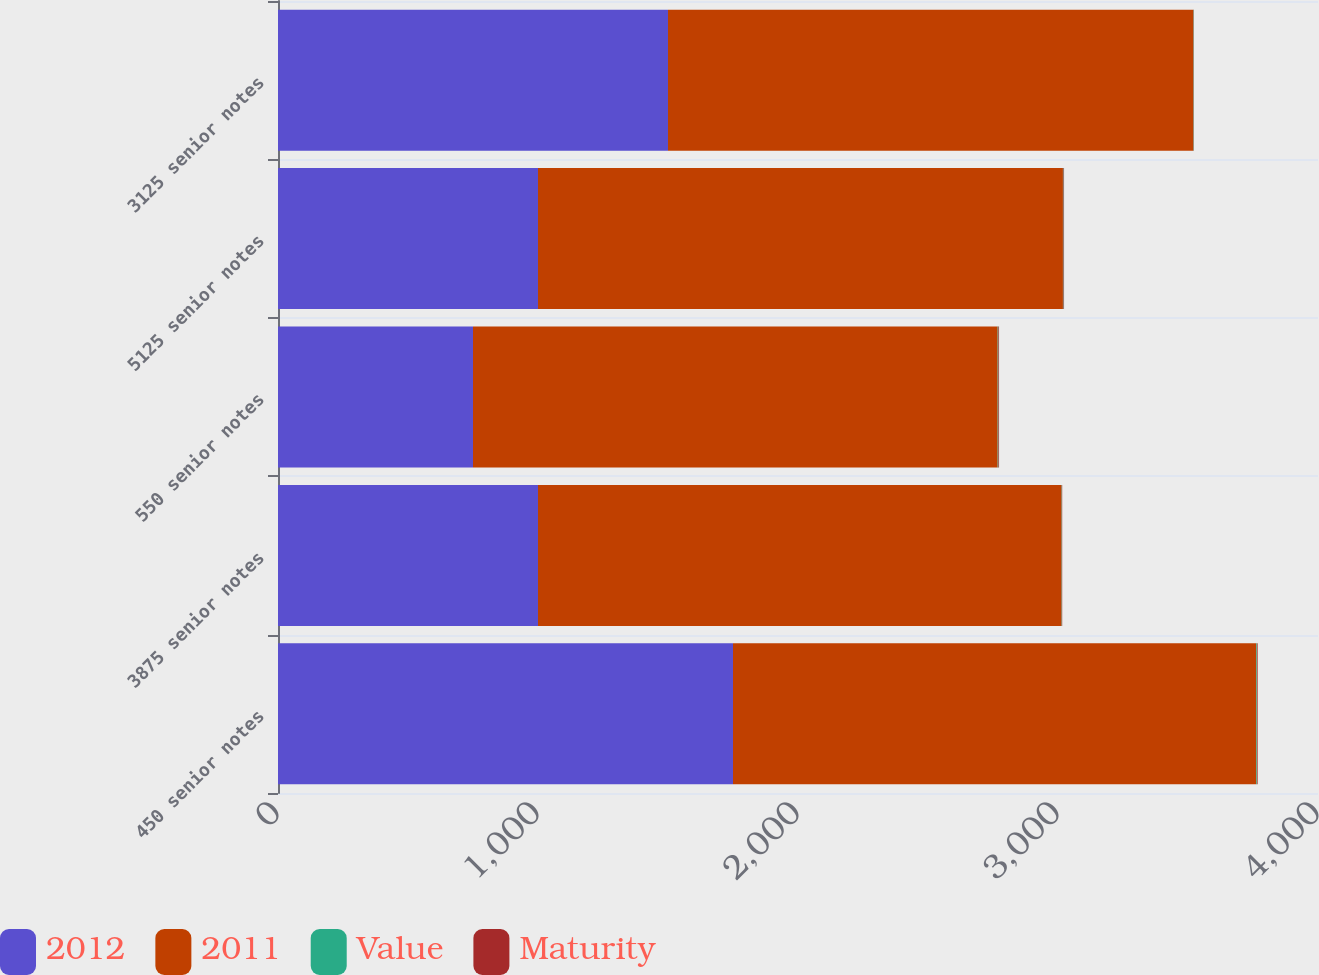Convert chart. <chart><loc_0><loc_0><loc_500><loc_500><stacked_bar_chart><ecel><fcel>450 senior notes<fcel>3875 senior notes<fcel>550 senior notes<fcel>5125 senior notes<fcel>3125 senior notes<nl><fcel>2012<fcel>1750<fcel>1000<fcel>750<fcel>1000<fcel>1500<nl><fcel>2011<fcel>2013<fcel>2014<fcel>2018<fcel>2019<fcel>2021<nl><fcel>Value<fcel>2.51<fcel>1.14<fcel>2.71<fcel>2.2<fcel>1.28<nl><fcel>Maturity<fcel>2.39<fcel>0.99<fcel>2.53<fcel>2.04<fcel>0.52<nl></chart> 